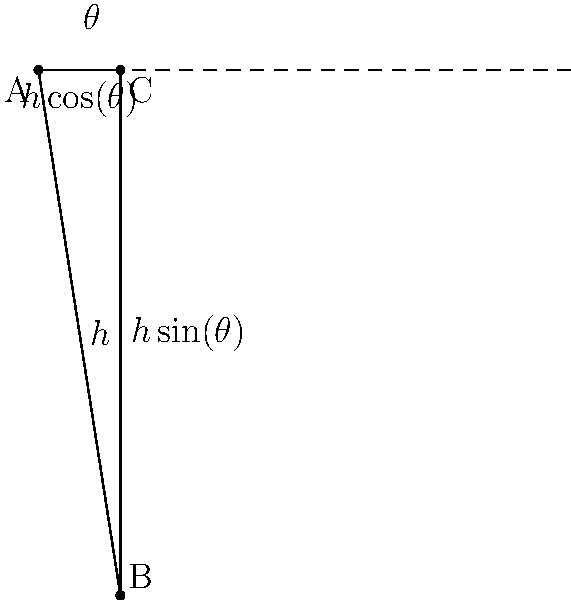As part of an energy efficiency initiative, your company plans to install solar panels on the roof. The effectiveness of the panels depends on the angle at which they are installed. Given that the height of the building is $h$ and the angle of the panels with respect to the horizontal is $\theta$, what angle $\theta$ maximizes the product of the panel's height above the ground ($h \sin(\theta)$) and its projection on the horizontal plane ($h \cos(\theta)$)? This product represents the panel's ability to capture both direct and diffuse sunlight. Let's approach this step-by-step:

1) The quantity we want to maximize is:
   $f(\theta) = (h \sin(\theta))(h \cos(\theta)) = h^2 \sin(\theta)\cos(\theta)$

2) We can simplify this using the trigonometric identity:
   $\sin(2\theta) = 2\sin(\theta)\cos(\theta)$

3) So our function becomes:
   $f(\theta) = \frac{1}{2}h^2 \sin(2\theta)$

4) To find the maximum, we need to differentiate $f(\theta)$ with respect to $\theta$ and set it to zero:
   $f'(\theta) = h^2 \cos(2\theta) = 0$

5) Solving this equation:
   $\cos(2\theta) = 0$
   $2\theta = \frac{\pi}{2}$ (we choose this solution as it's in the first quadrant)
   $\theta = \frac{\pi}{4} = 45°$

6) To confirm this is a maximum, we can check the second derivative:
   $f''(\theta) = -2h^2 \sin(2\theta)$
   At $\theta = 45°$, $f''(\theta) < 0$, confirming it's a maximum.

Therefore, the optimal angle for the solar panels is 45° to the horizontal.
Answer: 45° 